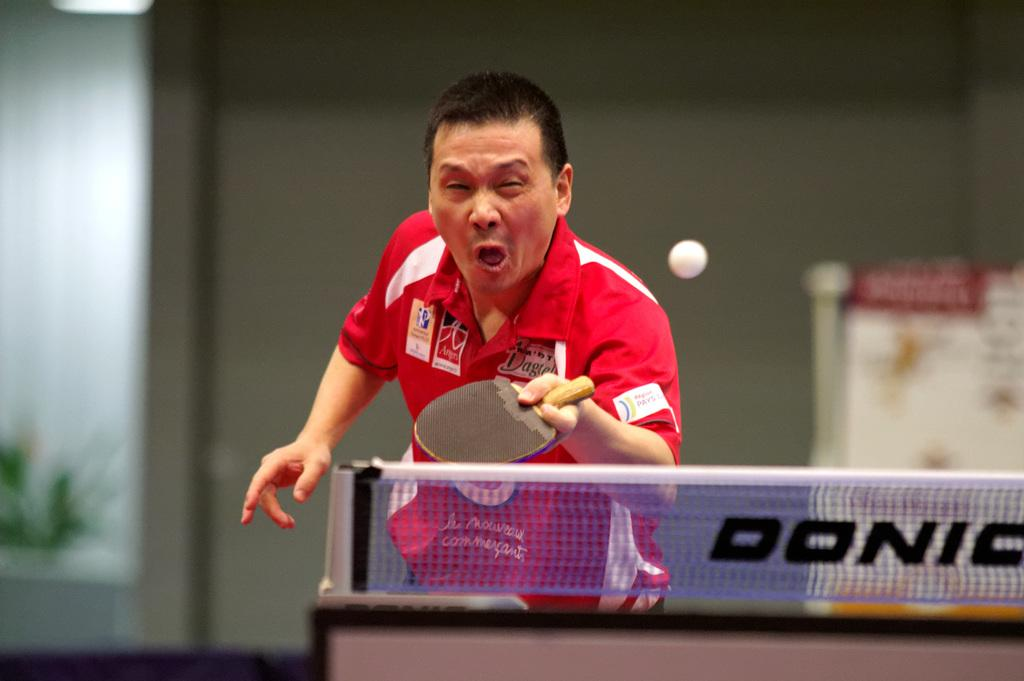Who is in the image? There is a man in the image. What is the man wearing? The man is wearing a red t-shirt. What object is the man holding? The man is holding a bat. What is on the table in front of the man? There is a ball on top of the table. What can be seen behind the man? The background of the image is a wall. Is the man's friend, the writer, standing next to him in the image? There is no friend or writer present in the image. 